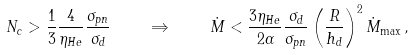Convert formula to latex. <formula><loc_0><loc_0><loc_500><loc_500>N _ { c } > \frac { 1 } { 3 } \frac { 4 } { \eta _ { H e } } \frac { \sigma _ { p n } } { \sigma _ { d } } \quad \Rightarrow \quad \dot { M } < \frac { 3 \eta _ { H e } } { 2 \alpha } \frac { \sigma _ { d } } { \sigma _ { p n } } \left ( \frac { R } { h _ { d } } \right ) ^ { 2 } \dot { M } _ { \max } \, ,</formula> 